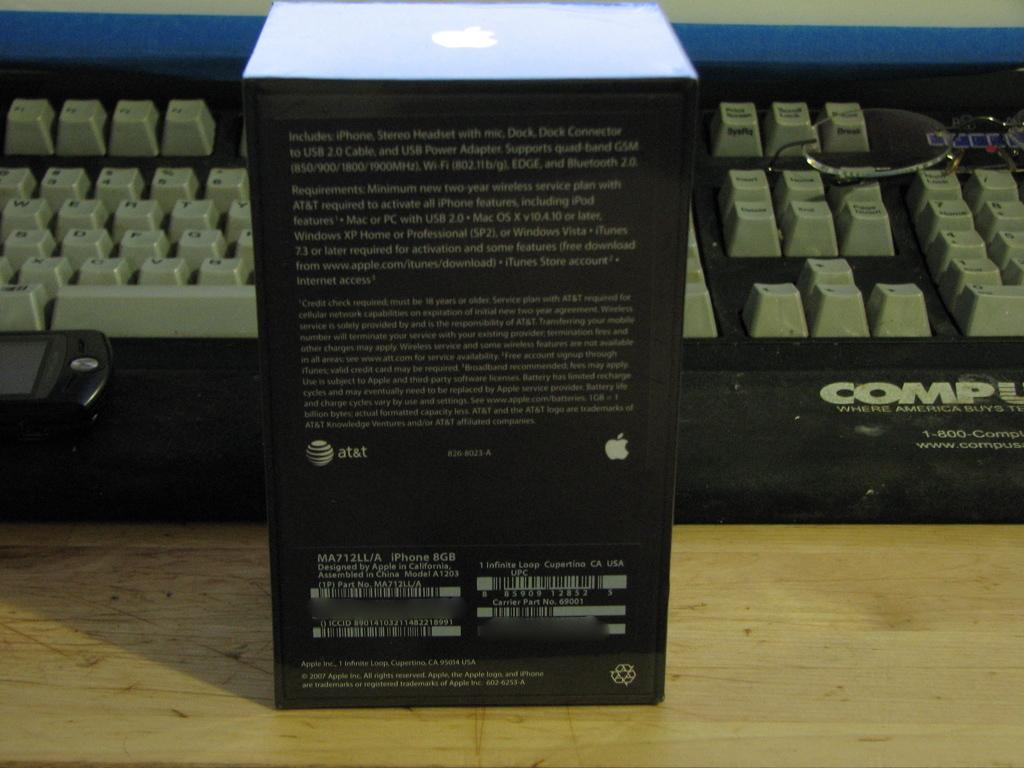<image>
Share a concise interpretation of the image provided. An iPhone box from ATT in fron of a computer Keyboard 